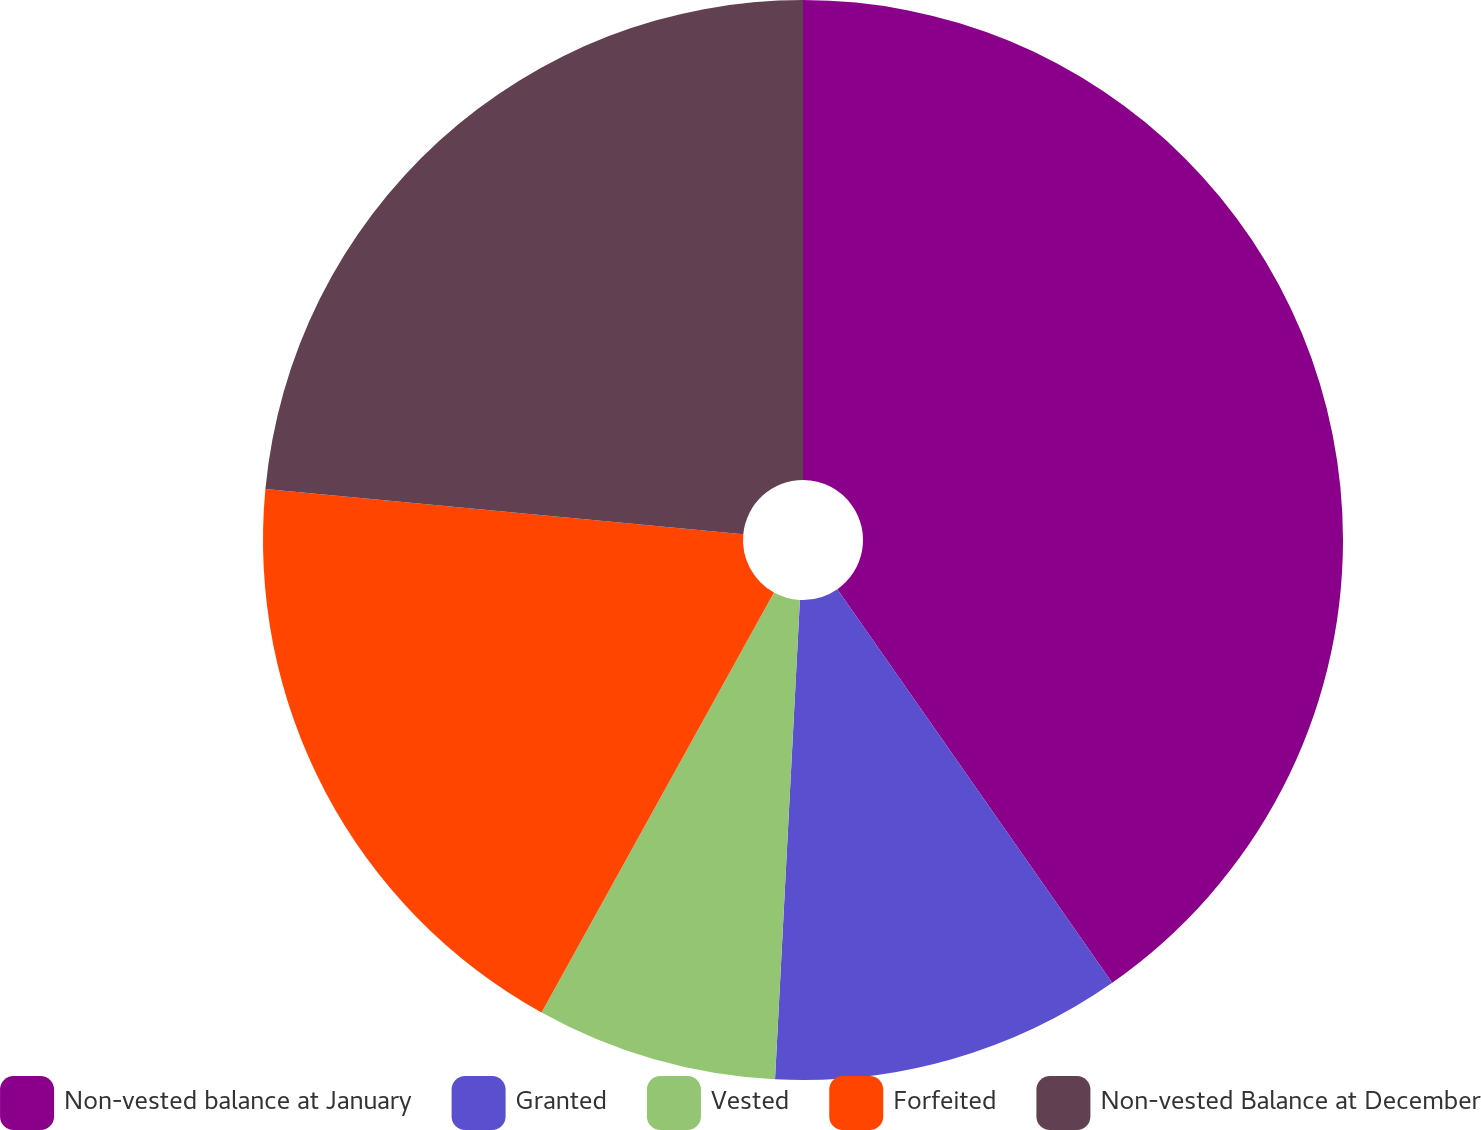Convert chart. <chart><loc_0><loc_0><loc_500><loc_500><pie_chart><fcel>Non-vested balance at January<fcel>Granted<fcel>Vested<fcel>Forfeited<fcel>Non-vested Balance at December<nl><fcel>40.3%<fcel>10.53%<fcel>7.22%<fcel>18.46%<fcel>23.5%<nl></chart> 